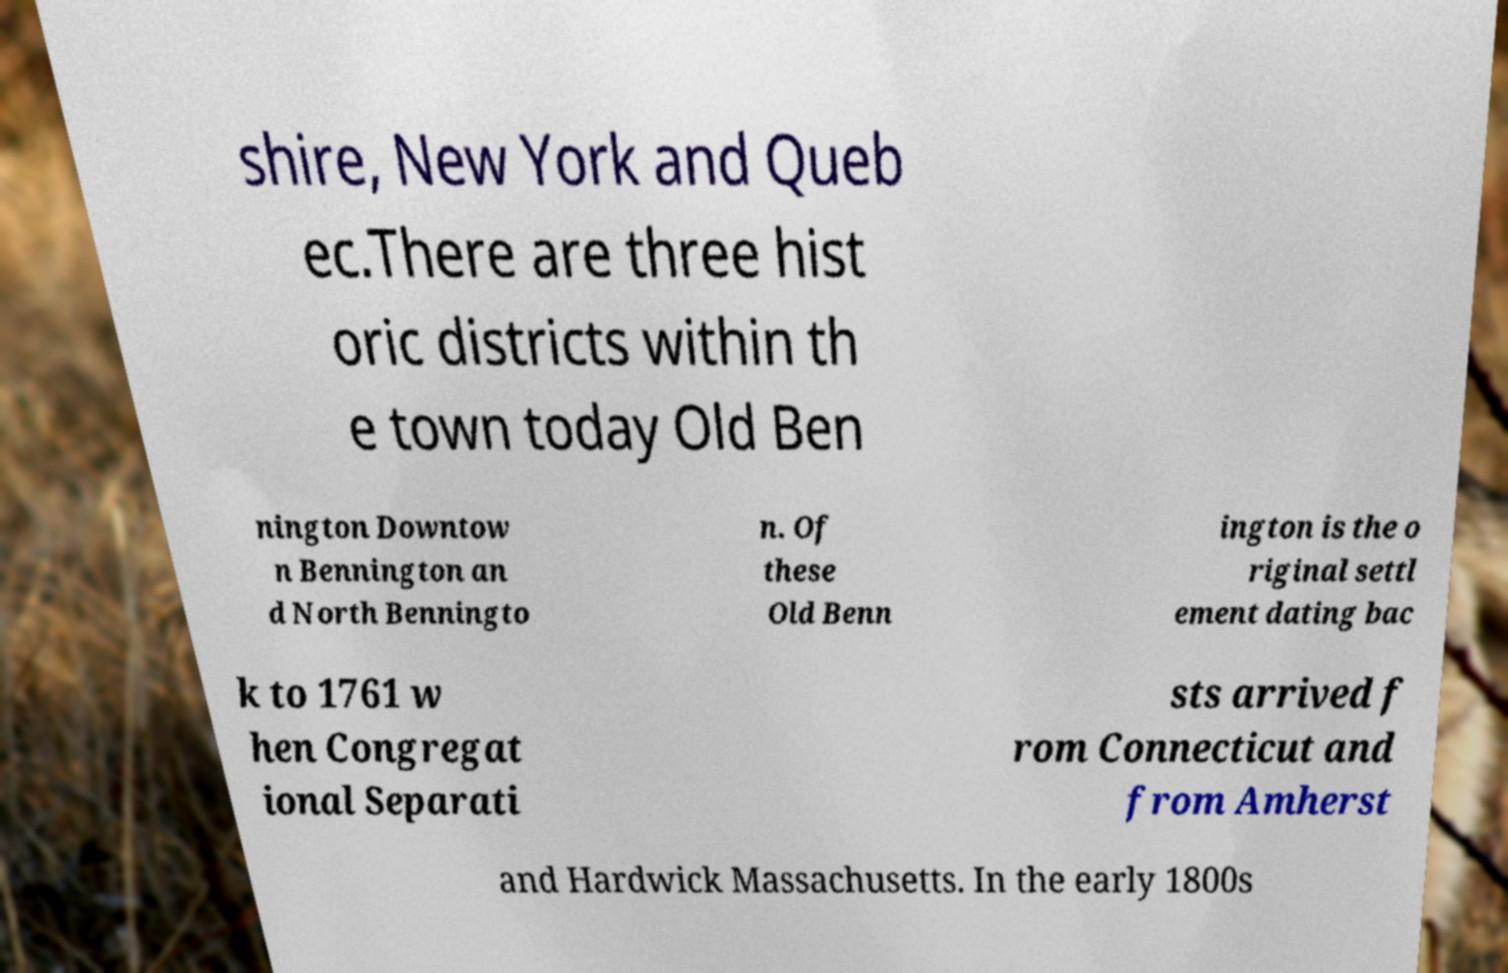Please read and relay the text visible in this image. What does it say? shire, New York and Queb ec.There are three hist oric districts within th e town today Old Ben nington Downtow n Bennington an d North Benningto n. Of these Old Benn ington is the o riginal settl ement dating bac k to 1761 w hen Congregat ional Separati sts arrived f rom Connecticut and from Amherst and Hardwick Massachusetts. In the early 1800s 